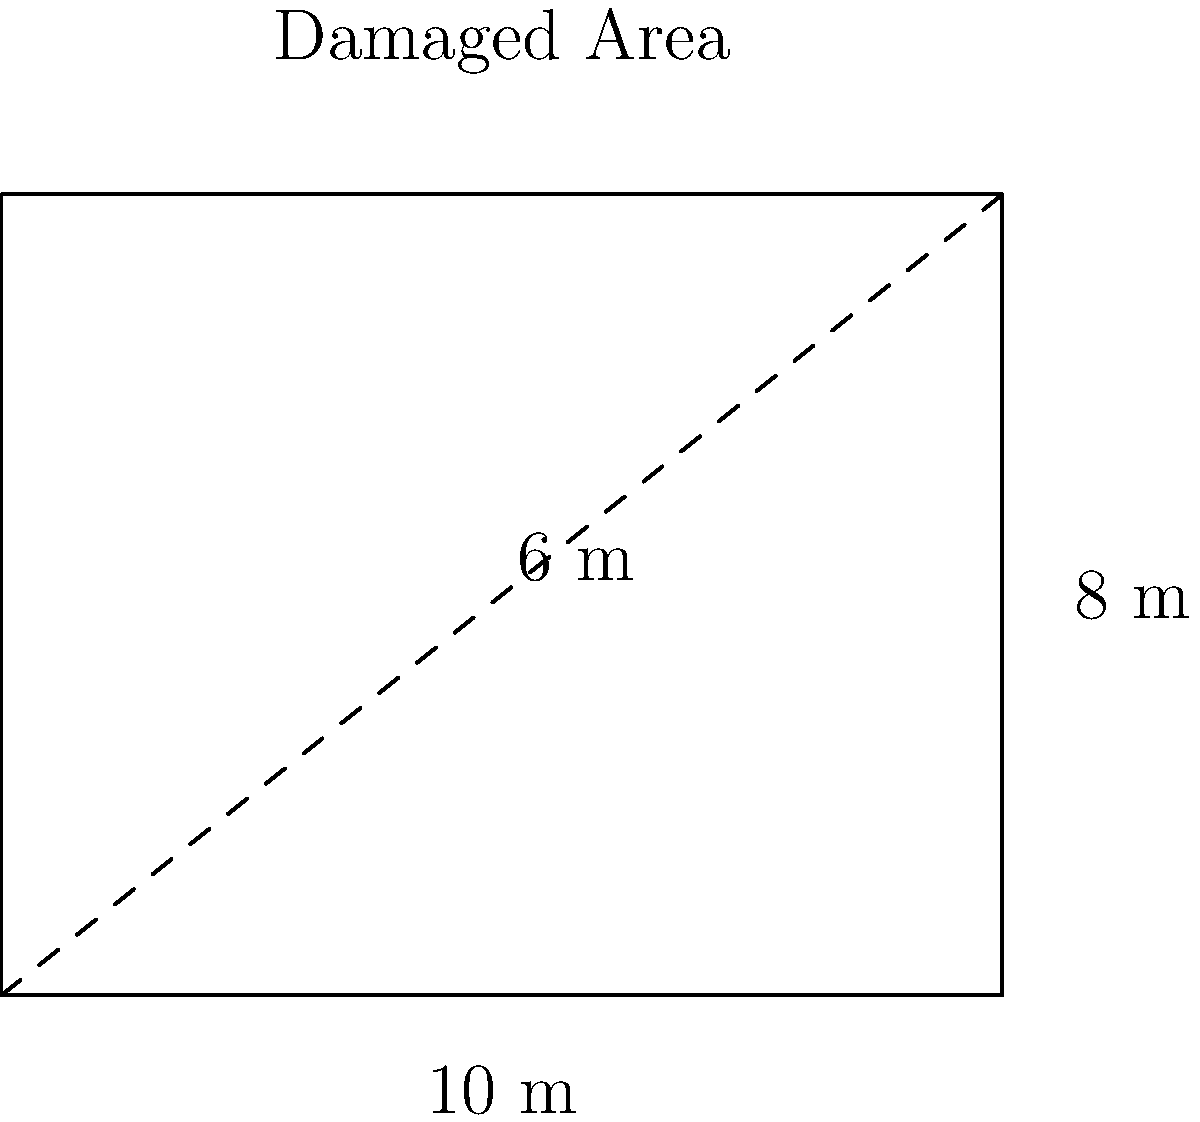As a homeowner assessing the damage to your property, you need to calculate the volume of debris to be removed. The damaged area is represented by a rectangular prism with a length of 10 meters, width of 8 meters, and an average height of 6 meters. What is the total volume of debris to be removed from your property? To calculate the volume of debris, we need to use the formula for the volume of a rectangular prism:

$$ V = l \times w \times h $$

Where:
$V$ = Volume
$l$ = Length
$w$ = Width
$h$ = Height

Given:
- Length ($l$) = 10 meters
- Width ($w$) = 8 meters
- Average height ($h$) = 6 meters

Let's plug these values into the formula:

$$ V = 10 \text{ m} \times 8 \text{ m} \times 6 \text{ m} $$

$$ V = 480 \text{ m}^3 $$

Therefore, the total volume of debris to be removed from your property is 480 cubic meters.
Answer: 480 m³ 